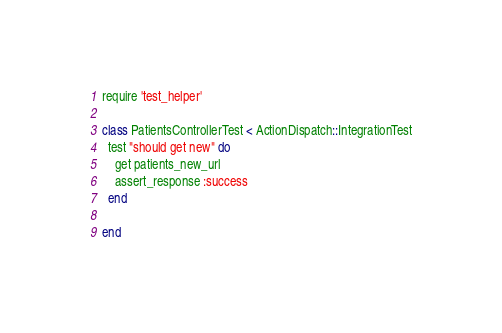<code> <loc_0><loc_0><loc_500><loc_500><_Ruby_>require 'test_helper'

class PatientsControllerTest < ActionDispatch::IntegrationTest
  test "should get new" do
    get patients_new_url
    assert_response :success
  end

end
</code> 